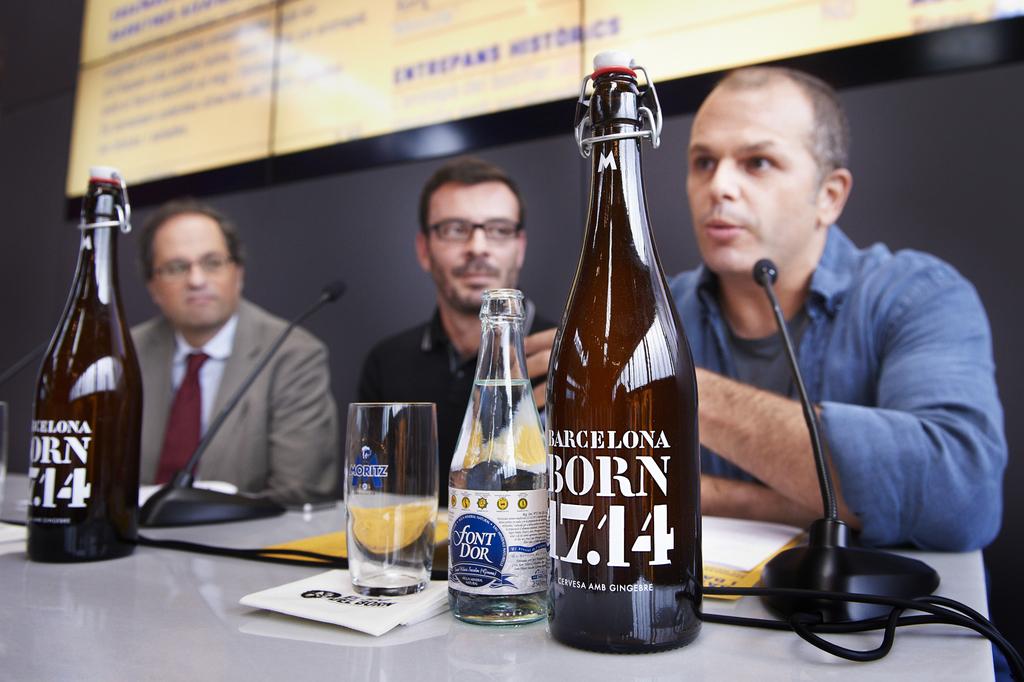What does the bottle say?
Your answer should be compact. Barcelona born 17.14. 